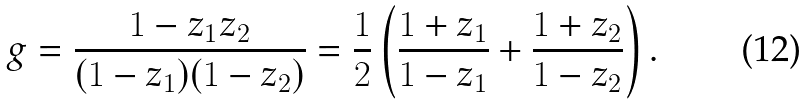Convert formula to latex. <formula><loc_0><loc_0><loc_500><loc_500>g = \frac { 1 - z _ { 1 } z _ { 2 } } { ( 1 - z _ { 1 } ) ( 1 - z _ { 2 } ) } = \frac { 1 } { 2 } \left ( \frac { 1 + z _ { 1 } } { 1 - z _ { 1 } } + \frac { 1 + z _ { 2 } } { 1 - z _ { 2 } } \right ) .</formula> 